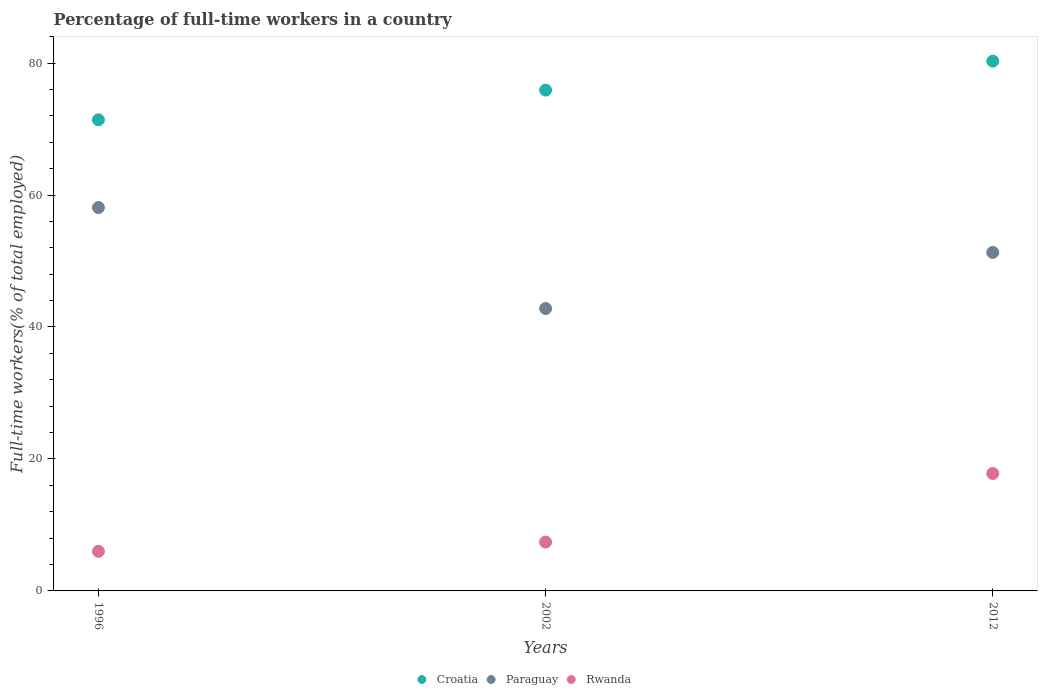Is the number of dotlines equal to the number of legend labels?
Ensure brevity in your answer.  Yes. Across all years, what is the maximum percentage of full-time workers in Paraguay?
Your answer should be very brief. 58.1. Across all years, what is the minimum percentage of full-time workers in Croatia?
Give a very brief answer. 71.4. In which year was the percentage of full-time workers in Paraguay maximum?
Make the answer very short. 1996. What is the total percentage of full-time workers in Paraguay in the graph?
Provide a short and direct response. 152.2. What is the difference between the percentage of full-time workers in Croatia in 1996 and that in 2012?
Keep it short and to the point. -8.9. What is the difference between the percentage of full-time workers in Rwanda in 2002 and the percentage of full-time workers in Croatia in 2012?
Provide a short and direct response. -72.9. What is the average percentage of full-time workers in Croatia per year?
Provide a short and direct response. 75.87. In the year 1996, what is the difference between the percentage of full-time workers in Rwanda and percentage of full-time workers in Croatia?
Offer a terse response. -65.4. What is the ratio of the percentage of full-time workers in Paraguay in 2002 to that in 2012?
Provide a short and direct response. 0.83. What is the difference between the highest and the second highest percentage of full-time workers in Rwanda?
Your answer should be compact. 10.4. What is the difference between the highest and the lowest percentage of full-time workers in Rwanda?
Make the answer very short. 11.8. Is it the case that in every year, the sum of the percentage of full-time workers in Rwanda and percentage of full-time workers in Croatia  is greater than the percentage of full-time workers in Paraguay?
Provide a short and direct response. Yes. Does the percentage of full-time workers in Croatia monotonically increase over the years?
Provide a succinct answer. Yes. Is the percentage of full-time workers in Rwanda strictly greater than the percentage of full-time workers in Paraguay over the years?
Keep it short and to the point. No. How many years are there in the graph?
Offer a very short reply. 3. What is the difference between two consecutive major ticks on the Y-axis?
Provide a short and direct response. 20. Does the graph contain any zero values?
Your answer should be very brief. No. Where does the legend appear in the graph?
Offer a very short reply. Bottom center. How are the legend labels stacked?
Provide a succinct answer. Horizontal. What is the title of the graph?
Your answer should be compact. Percentage of full-time workers in a country. What is the label or title of the Y-axis?
Offer a terse response. Full-time workers(% of total employed). What is the Full-time workers(% of total employed) of Croatia in 1996?
Your answer should be very brief. 71.4. What is the Full-time workers(% of total employed) of Paraguay in 1996?
Keep it short and to the point. 58.1. What is the Full-time workers(% of total employed) in Croatia in 2002?
Make the answer very short. 75.9. What is the Full-time workers(% of total employed) of Paraguay in 2002?
Offer a very short reply. 42.8. What is the Full-time workers(% of total employed) of Rwanda in 2002?
Offer a terse response. 7.4. What is the Full-time workers(% of total employed) in Croatia in 2012?
Provide a succinct answer. 80.3. What is the Full-time workers(% of total employed) in Paraguay in 2012?
Keep it short and to the point. 51.3. What is the Full-time workers(% of total employed) of Rwanda in 2012?
Offer a terse response. 17.8. Across all years, what is the maximum Full-time workers(% of total employed) in Croatia?
Make the answer very short. 80.3. Across all years, what is the maximum Full-time workers(% of total employed) in Paraguay?
Your answer should be very brief. 58.1. Across all years, what is the maximum Full-time workers(% of total employed) of Rwanda?
Your response must be concise. 17.8. Across all years, what is the minimum Full-time workers(% of total employed) in Croatia?
Ensure brevity in your answer.  71.4. Across all years, what is the minimum Full-time workers(% of total employed) in Paraguay?
Provide a succinct answer. 42.8. Across all years, what is the minimum Full-time workers(% of total employed) of Rwanda?
Keep it short and to the point. 6. What is the total Full-time workers(% of total employed) of Croatia in the graph?
Give a very brief answer. 227.6. What is the total Full-time workers(% of total employed) of Paraguay in the graph?
Your answer should be compact. 152.2. What is the total Full-time workers(% of total employed) of Rwanda in the graph?
Your response must be concise. 31.2. What is the difference between the Full-time workers(% of total employed) of Croatia in 1996 and that in 2002?
Offer a terse response. -4.5. What is the difference between the Full-time workers(% of total employed) in Rwanda in 1996 and that in 2002?
Provide a succinct answer. -1.4. What is the difference between the Full-time workers(% of total employed) in Paraguay in 1996 and that in 2012?
Ensure brevity in your answer.  6.8. What is the difference between the Full-time workers(% of total employed) of Rwanda in 1996 and that in 2012?
Make the answer very short. -11.8. What is the difference between the Full-time workers(% of total employed) in Rwanda in 2002 and that in 2012?
Make the answer very short. -10.4. What is the difference between the Full-time workers(% of total employed) in Croatia in 1996 and the Full-time workers(% of total employed) in Paraguay in 2002?
Your answer should be compact. 28.6. What is the difference between the Full-time workers(% of total employed) in Paraguay in 1996 and the Full-time workers(% of total employed) in Rwanda in 2002?
Provide a short and direct response. 50.7. What is the difference between the Full-time workers(% of total employed) in Croatia in 1996 and the Full-time workers(% of total employed) in Paraguay in 2012?
Your answer should be very brief. 20.1. What is the difference between the Full-time workers(% of total employed) in Croatia in 1996 and the Full-time workers(% of total employed) in Rwanda in 2012?
Your answer should be compact. 53.6. What is the difference between the Full-time workers(% of total employed) of Paraguay in 1996 and the Full-time workers(% of total employed) of Rwanda in 2012?
Your response must be concise. 40.3. What is the difference between the Full-time workers(% of total employed) of Croatia in 2002 and the Full-time workers(% of total employed) of Paraguay in 2012?
Make the answer very short. 24.6. What is the difference between the Full-time workers(% of total employed) in Croatia in 2002 and the Full-time workers(% of total employed) in Rwanda in 2012?
Your answer should be compact. 58.1. What is the difference between the Full-time workers(% of total employed) in Paraguay in 2002 and the Full-time workers(% of total employed) in Rwanda in 2012?
Offer a terse response. 25. What is the average Full-time workers(% of total employed) of Croatia per year?
Keep it short and to the point. 75.87. What is the average Full-time workers(% of total employed) in Paraguay per year?
Ensure brevity in your answer.  50.73. What is the average Full-time workers(% of total employed) of Rwanda per year?
Provide a short and direct response. 10.4. In the year 1996, what is the difference between the Full-time workers(% of total employed) in Croatia and Full-time workers(% of total employed) in Paraguay?
Provide a succinct answer. 13.3. In the year 1996, what is the difference between the Full-time workers(% of total employed) in Croatia and Full-time workers(% of total employed) in Rwanda?
Ensure brevity in your answer.  65.4. In the year 1996, what is the difference between the Full-time workers(% of total employed) in Paraguay and Full-time workers(% of total employed) in Rwanda?
Offer a very short reply. 52.1. In the year 2002, what is the difference between the Full-time workers(% of total employed) of Croatia and Full-time workers(% of total employed) of Paraguay?
Your answer should be compact. 33.1. In the year 2002, what is the difference between the Full-time workers(% of total employed) of Croatia and Full-time workers(% of total employed) of Rwanda?
Make the answer very short. 68.5. In the year 2002, what is the difference between the Full-time workers(% of total employed) in Paraguay and Full-time workers(% of total employed) in Rwanda?
Provide a succinct answer. 35.4. In the year 2012, what is the difference between the Full-time workers(% of total employed) in Croatia and Full-time workers(% of total employed) in Rwanda?
Provide a succinct answer. 62.5. In the year 2012, what is the difference between the Full-time workers(% of total employed) of Paraguay and Full-time workers(% of total employed) of Rwanda?
Keep it short and to the point. 33.5. What is the ratio of the Full-time workers(% of total employed) of Croatia in 1996 to that in 2002?
Your answer should be very brief. 0.94. What is the ratio of the Full-time workers(% of total employed) of Paraguay in 1996 to that in 2002?
Your answer should be compact. 1.36. What is the ratio of the Full-time workers(% of total employed) in Rwanda in 1996 to that in 2002?
Your response must be concise. 0.81. What is the ratio of the Full-time workers(% of total employed) of Croatia in 1996 to that in 2012?
Your answer should be compact. 0.89. What is the ratio of the Full-time workers(% of total employed) in Paraguay in 1996 to that in 2012?
Provide a succinct answer. 1.13. What is the ratio of the Full-time workers(% of total employed) in Rwanda in 1996 to that in 2012?
Make the answer very short. 0.34. What is the ratio of the Full-time workers(% of total employed) of Croatia in 2002 to that in 2012?
Give a very brief answer. 0.95. What is the ratio of the Full-time workers(% of total employed) of Paraguay in 2002 to that in 2012?
Offer a very short reply. 0.83. What is the ratio of the Full-time workers(% of total employed) in Rwanda in 2002 to that in 2012?
Your answer should be very brief. 0.42. What is the difference between the highest and the second highest Full-time workers(% of total employed) of Croatia?
Your answer should be compact. 4.4. What is the difference between the highest and the second highest Full-time workers(% of total employed) in Paraguay?
Offer a terse response. 6.8. What is the difference between the highest and the second highest Full-time workers(% of total employed) of Rwanda?
Provide a succinct answer. 10.4. What is the difference between the highest and the lowest Full-time workers(% of total employed) in Paraguay?
Ensure brevity in your answer.  15.3. 